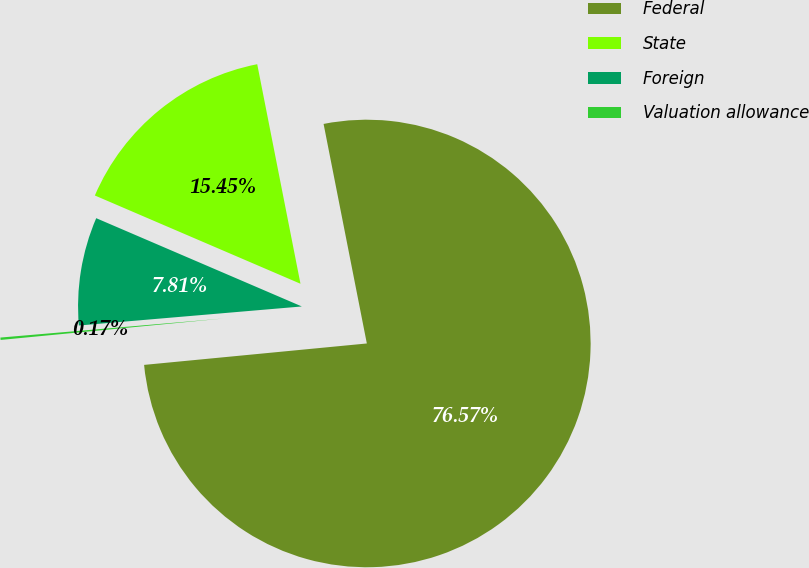Convert chart. <chart><loc_0><loc_0><loc_500><loc_500><pie_chart><fcel>Federal<fcel>State<fcel>Foreign<fcel>Valuation allowance<nl><fcel>76.57%<fcel>15.45%<fcel>7.81%<fcel>0.17%<nl></chart> 